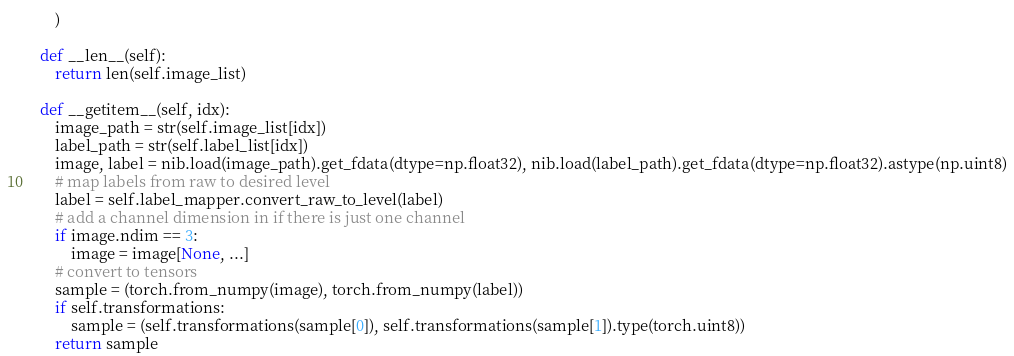<code> <loc_0><loc_0><loc_500><loc_500><_Python_>        )

    def __len__(self):
        return len(self.image_list)

    def __getitem__(self, idx):
        image_path = str(self.image_list[idx])
        label_path = str(self.label_list[idx])
        image, label = nib.load(image_path).get_fdata(dtype=np.float32), nib.load(label_path).get_fdata(dtype=np.float32).astype(np.uint8)
        # map labels from raw to desired level
        label = self.label_mapper.convert_raw_to_level(label)
        # add a channel dimension in if there is just one channel
        if image.ndim == 3:
            image = image[None, ...]
        # convert to tensors
        sample = (torch.from_numpy(image), torch.from_numpy(label))
        if self.transformations:
            sample = (self.transformations(sample[0]), self.transformations(sample[1]).type(torch.uint8))
        return sample
</code> 